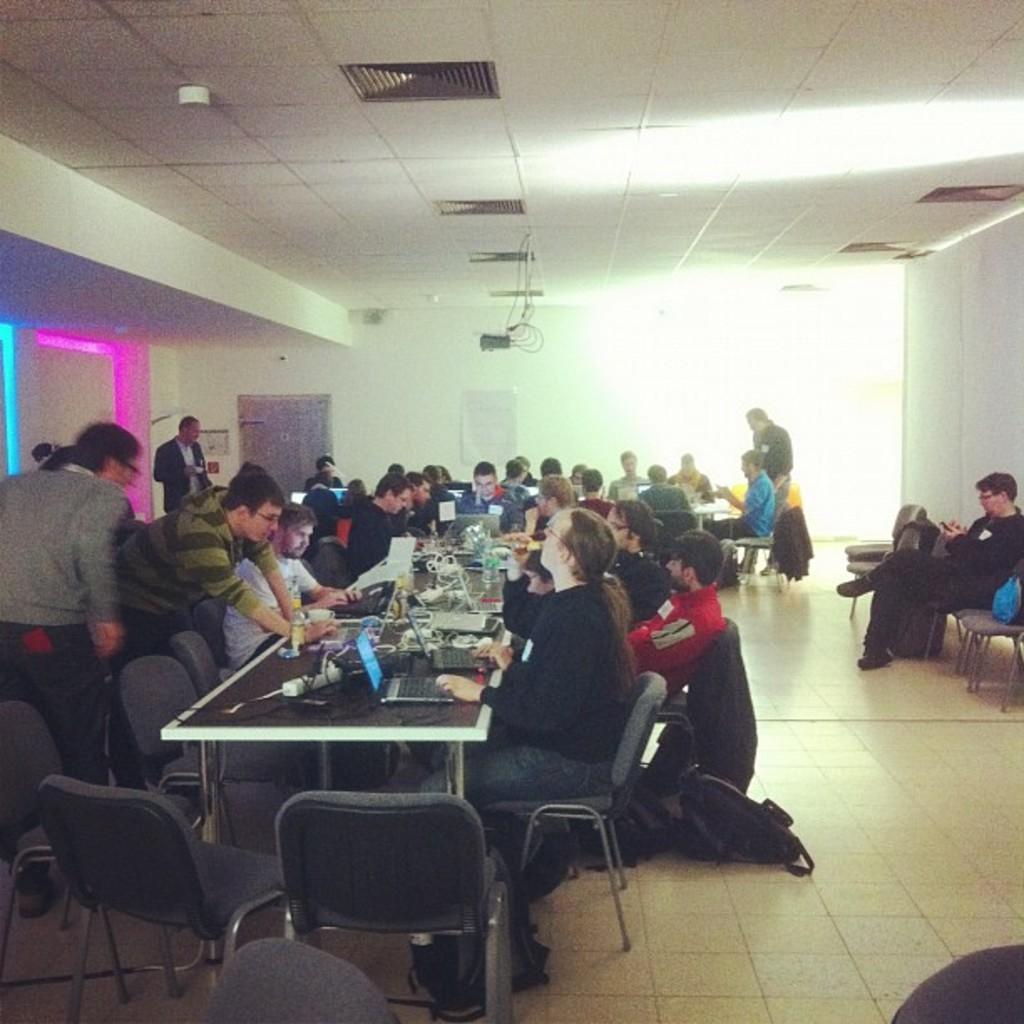Describe this image in one or two sentences. there are some people sitting in the chairs on the floor, in front of a table. Some of them was standing. In the right side, there is a man sitting in the chair. On the table there are some food items, laptops , glasses were there. In the background there is a light and a wall here. 